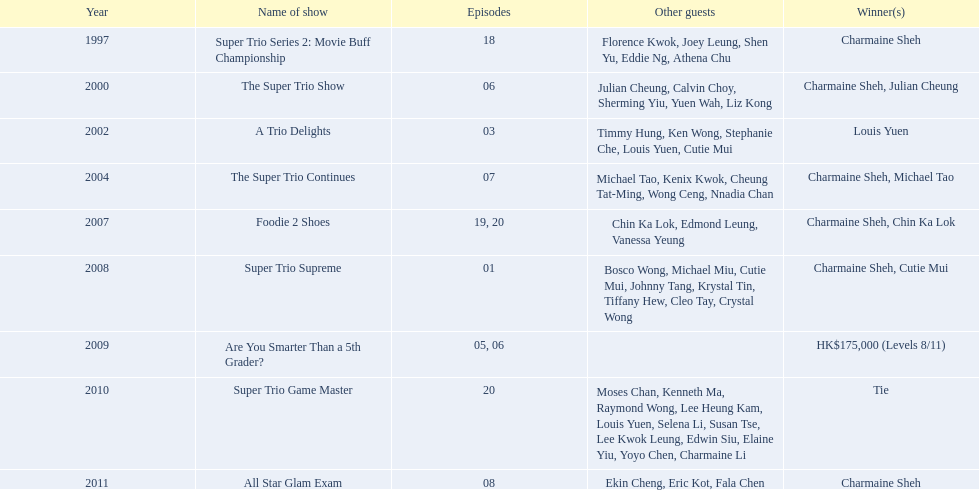How many episodes was charmaine sheh on in the variety show super trio 2: movie buff champions 18. 